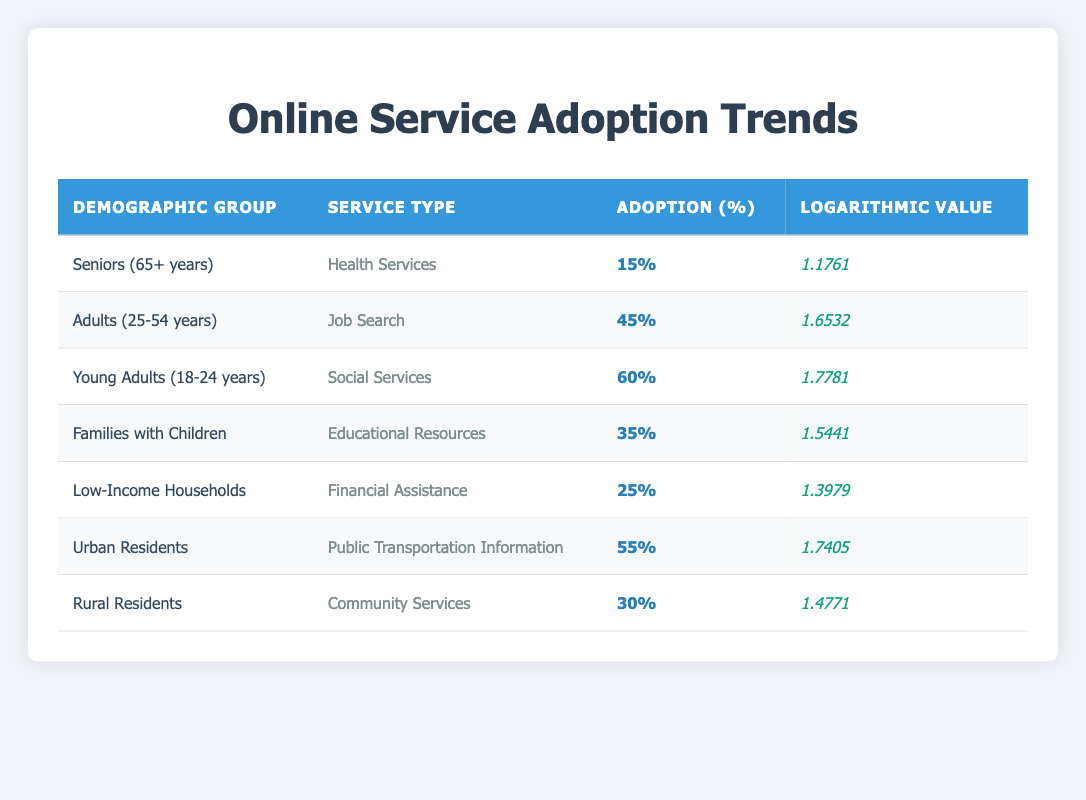What is the percentage adoption of Health Services among Seniors? The table shows that Seniors (65+ years) have a percentage adoption of 15% for Health Services. This can be directly retrieved from the relevant row in the table.
Answer: 15% Which demographic group has the highest percentage adoption for online services? The highest percentage adoption is recorded for Young Adults (18-24 years) with an adoption rate of 60% for Social Services. This is determined by comparing the percentage adoption values in the table.
Answer: 60% What is the difference in percentage adoption between Young Adults and Low-Income Households? Young Adults (18-24 years) have a 60% adoption rate, while Low-Income Households have a 25% adoption rate. The difference is 60% - 25% = 35%. This involves simple subtraction of the two values.
Answer: 35% Is the percentage adoption for Urban Residents greater than that for Families with Children? Urban Residents have a percentage adoption of 55% for Public Transportation Information, and Families with Children have a 35% adoption for Educational Resources. Since 55% is greater than 35%, the answer is affirmative.
Answer: Yes What is the average percentage adoption across all demographic groups listed in the table? To find the average, sum all the percentage adoptions: 15 + 45 + 60 + 35 + 25 + 55 + 30 = 265. There are 7 groups, so the average is 265 / 7 = 37.857, which can be rounded to 37.86.
Answer: 37.86 